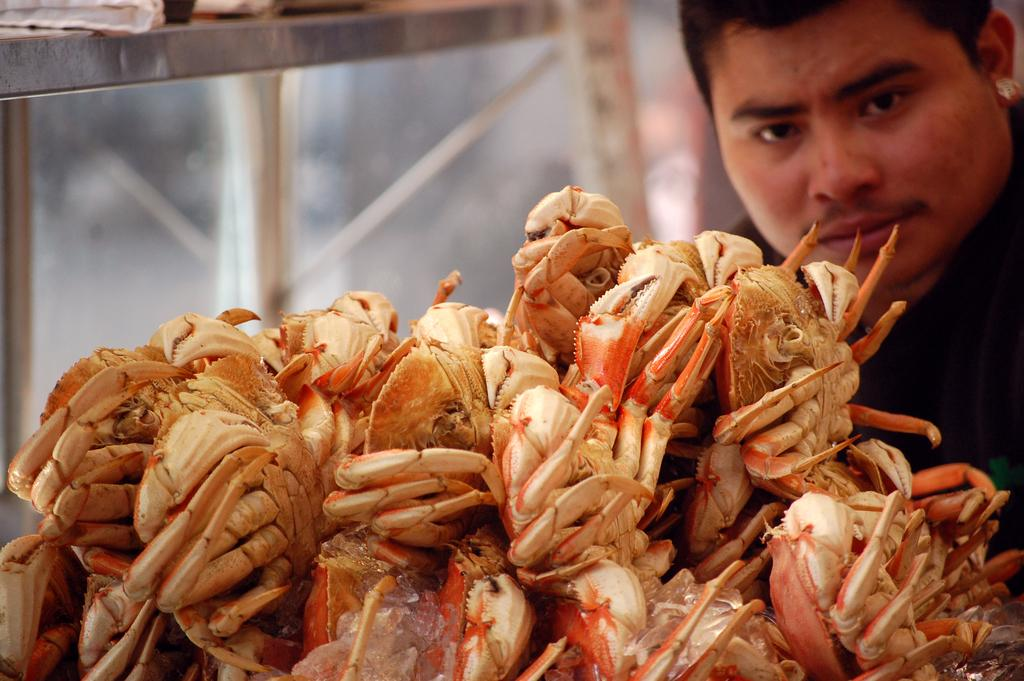What type of animals are in the image? There are crabs in the image. What is the man in the image doing? The man is looking at the crabs. What is the range of the crabs' mass in the image? There is no information provided about the mass of the crabs, so it is impossible to determine their range. 